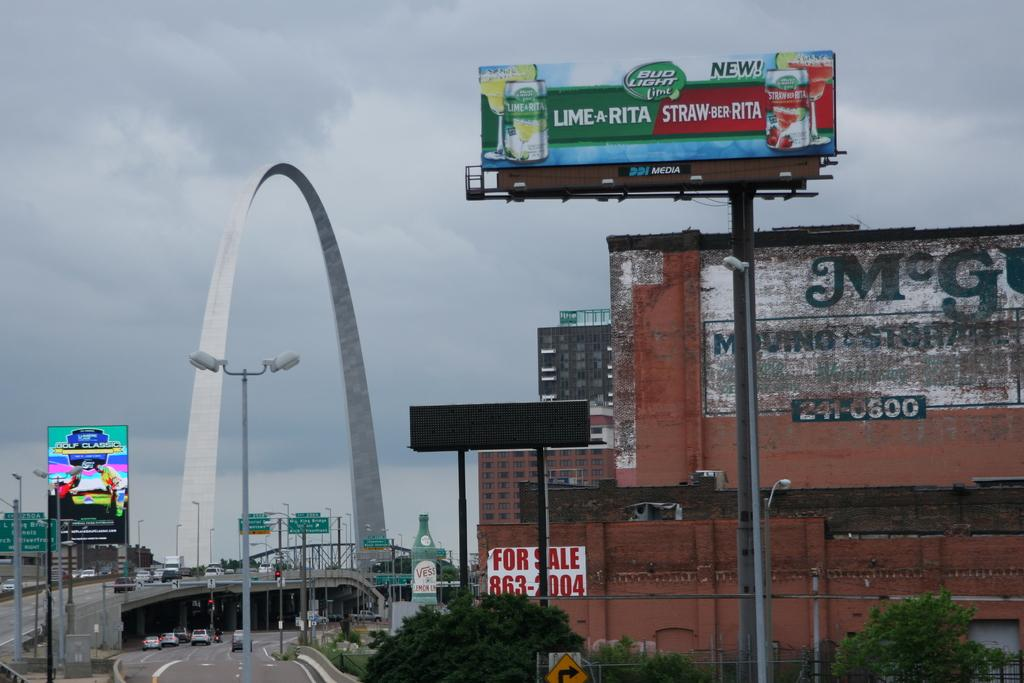<image>
Describe the image concisely. A billboard for new drinks from Bud Light is to the right of a giant arch. 